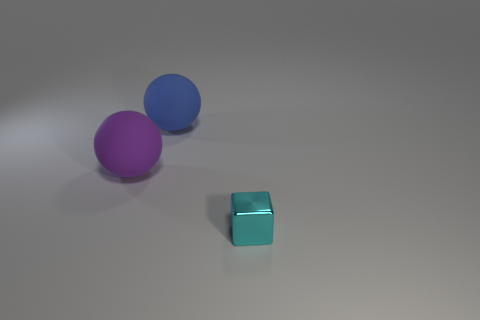Add 2 blue spheres. How many objects exist? 5 Subtract 0 gray cubes. How many objects are left? 3 Subtract all balls. How many objects are left? 1 Subtract all big gray rubber objects. Subtract all large purple rubber things. How many objects are left? 2 Add 3 shiny things. How many shiny things are left? 4 Add 3 blue rubber balls. How many blue rubber balls exist? 4 